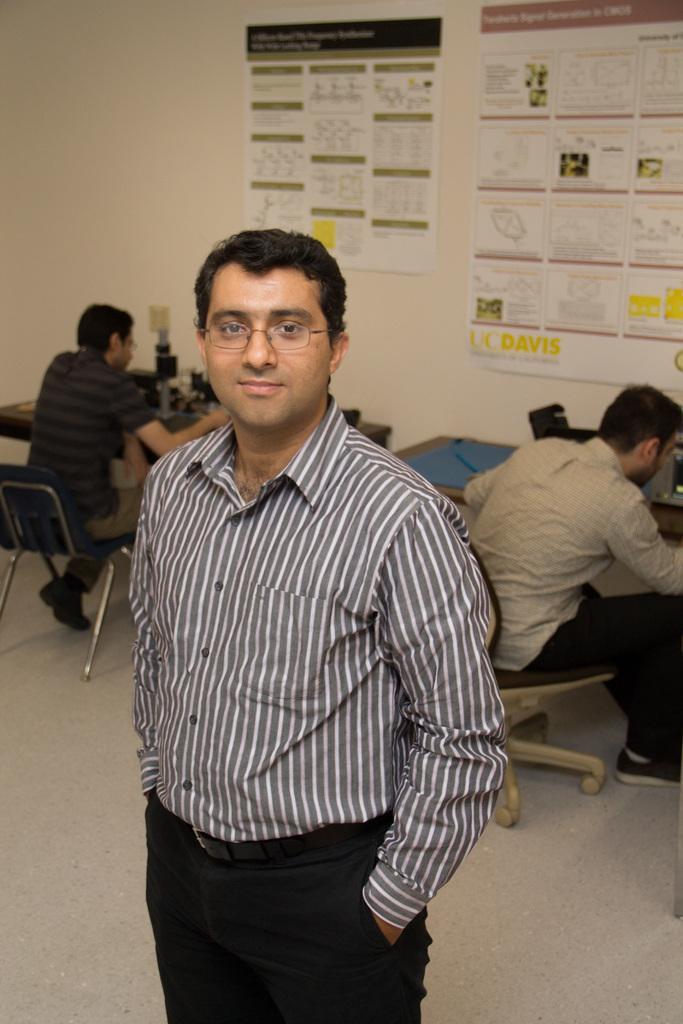Could you give a brief overview of what you see in this image? In this picture we can see three people, one man is standing and two men are sitting on chairs in front of table, in the background we can see some calendars and some charts and also we can see a wall, the man in front is wearing shirt and pants. 